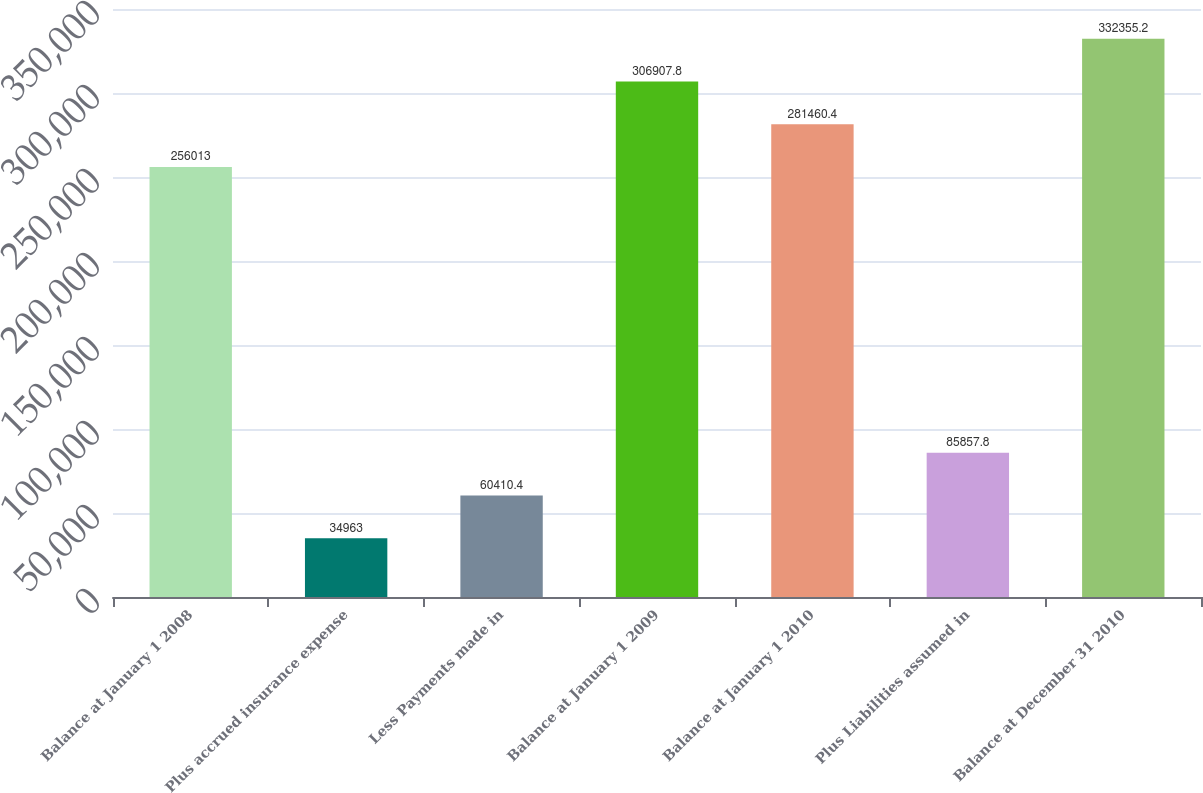Convert chart. <chart><loc_0><loc_0><loc_500><loc_500><bar_chart><fcel>Balance at January 1 2008<fcel>Plus accrued insurance expense<fcel>Less Payments made in<fcel>Balance at January 1 2009<fcel>Balance at January 1 2010<fcel>Plus Liabilities assumed in<fcel>Balance at December 31 2010<nl><fcel>256013<fcel>34963<fcel>60410.4<fcel>306908<fcel>281460<fcel>85857.8<fcel>332355<nl></chart> 